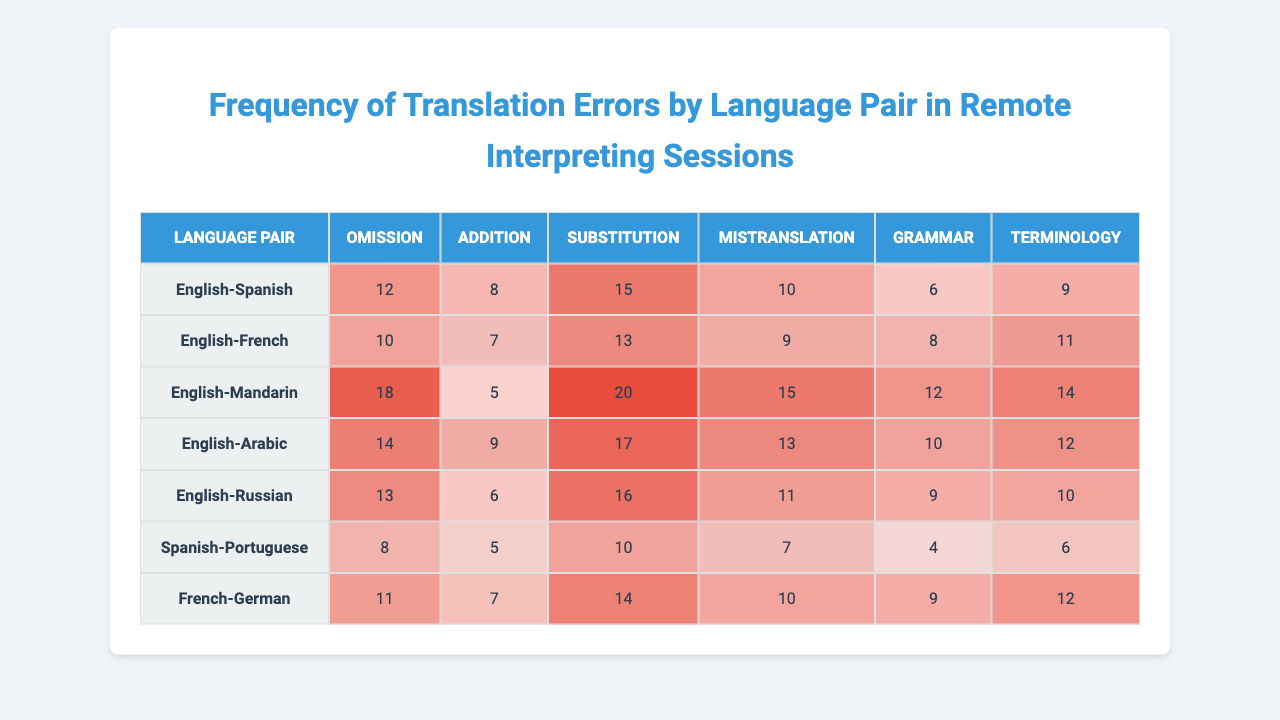What is the highest recorded error type for the English-Mandarin pair? The English-Mandarin pair has the highest recorded error type for "Substitution," which shows a count of 20.
Answer: Substitution Which language pair has the lowest total number of errors? To find the total errors for each language pair, we need to sum the counts of each error type. The Spanish-Portuguese pair has 40 total errors (8 + 5 + 10 + 7 + 4 + 6). This is the lowest compared to others.
Answer: Spanish-Portuguese How many more "Omissions" are there in English-Mandarin compared to English-Spanish? The English-Mandarin pair has 18 "Omissions," while the English-Spanish pair has 12. The difference is 18 - 12 = 6 more.
Answer: 6 Is "Addition" more frequent in English-Arabic than in English-Russian? The English-Arabic pair has 9 "Additions," while the English-Russian pair has 6. Therefore, "Addition" is indeed more frequent in English-Arabic.
Answer: Yes What is the total number of "Mistranslations" across all language pairs? To calculate, we sum the "Mistranslation" values across all language pairs: 10 + 9 + 15 + 13 + 11 + 7 + 10 = 75.
Answer: 75 Which language pair has the highest amount of "Grammar" errors, and what is the value? By analyzing the "Grammar" column, the English-Mandarin pair has the highest count of 12 errors.
Answer: English-Mandarin; 12 Are there more "Terminology" errors in English-French than in Spanish-Portuguese? The English-French pair has 11 "Terminology" errors, while Spanish-Portuguese has 6. Thus, there are more in English-French.
Answer: Yes If we average the "Substitution" errors for all language pairs, what is the result? The "Substitution" errors are: 15, 13, 20, 17, 16, 10, 14. The average is (15 + 13 + 20 + 17 + 16 + 10 + 14) / 7 = 15.
Answer: 15 Which error type has the highest total count across all language pairs? Summing each error type, "Omission" totals 91, while "Addition" yields 54, "Substitution" totals 105, "Mistranslation" sums to 75, "Grammar" is 66, and "Terminology" totals 64. So "Substitution" is the highest.
Answer: Substitution How many error types exceed 10 occurrences for the English-Russian language pair? Looking at the English-Russian pair, the error types exceeding 10 are "Omission" (13), "Substitution" (16), and "Mistranslation" (11). This totals 3 error types.
Answer: 3 